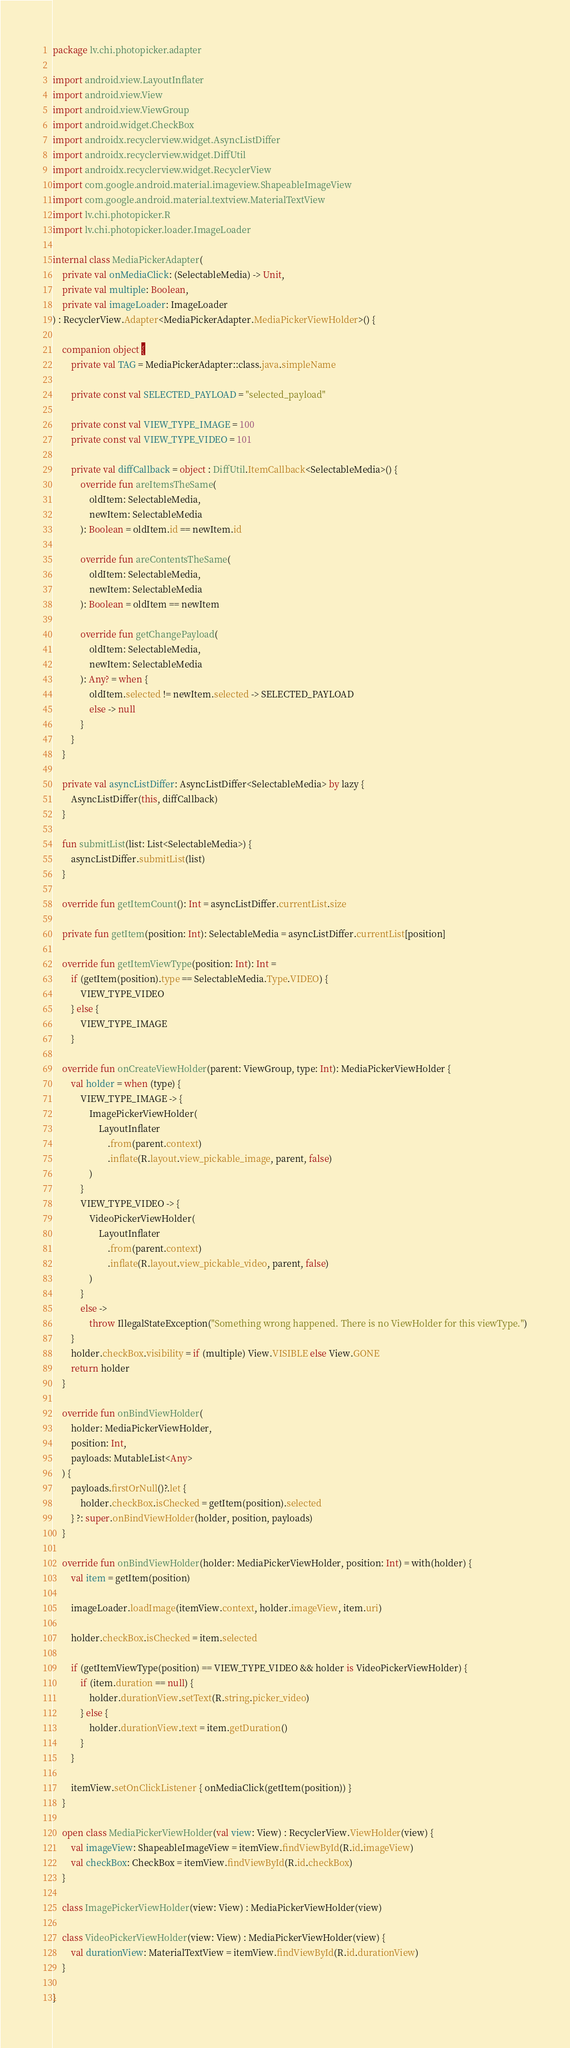Convert code to text. <code><loc_0><loc_0><loc_500><loc_500><_Kotlin_>package lv.chi.photopicker.adapter

import android.view.LayoutInflater
import android.view.View
import android.view.ViewGroup
import android.widget.CheckBox
import androidx.recyclerview.widget.AsyncListDiffer
import androidx.recyclerview.widget.DiffUtil
import androidx.recyclerview.widget.RecyclerView
import com.google.android.material.imageview.ShapeableImageView
import com.google.android.material.textview.MaterialTextView
import lv.chi.photopicker.R
import lv.chi.photopicker.loader.ImageLoader

internal class MediaPickerAdapter(
    private val onMediaClick: (SelectableMedia) -> Unit,
    private val multiple: Boolean,
    private val imageLoader: ImageLoader
) : RecyclerView.Adapter<MediaPickerAdapter.MediaPickerViewHolder>() {

    companion object {
        private val TAG = MediaPickerAdapter::class.java.simpleName

        private const val SELECTED_PAYLOAD = "selected_payload"

        private const val VIEW_TYPE_IMAGE = 100
        private const val VIEW_TYPE_VIDEO = 101

        private val diffCallback = object : DiffUtil.ItemCallback<SelectableMedia>() {
            override fun areItemsTheSame(
                oldItem: SelectableMedia,
                newItem: SelectableMedia
            ): Boolean = oldItem.id == newItem.id

            override fun areContentsTheSame(
                oldItem: SelectableMedia,
                newItem: SelectableMedia
            ): Boolean = oldItem == newItem

            override fun getChangePayload(
                oldItem: SelectableMedia,
                newItem: SelectableMedia
            ): Any? = when {
                oldItem.selected != newItem.selected -> SELECTED_PAYLOAD
                else -> null
            }
        }
    }

    private val asyncListDiffer: AsyncListDiffer<SelectableMedia> by lazy {
        AsyncListDiffer(this, diffCallback)
    }

    fun submitList(list: List<SelectableMedia>) {
        asyncListDiffer.submitList(list)
    }

    override fun getItemCount(): Int = asyncListDiffer.currentList.size

    private fun getItem(position: Int): SelectableMedia = asyncListDiffer.currentList[position]

    override fun getItemViewType(position: Int): Int =
        if (getItem(position).type == SelectableMedia.Type.VIDEO) {
            VIEW_TYPE_VIDEO
        } else {
            VIEW_TYPE_IMAGE
        }

    override fun onCreateViewHolder(parent: ViewGroup, type: Int): MediaPickerViewHolder {
        val holder = when (type) {
            VIEW_TYPE_IMAGE -> {
                ImagePickerViewHolder(
                    LayoutInflater
                        .from(parent.context)
                        .inflate(R.layout.view_pickable_image, parent, false)
                )
            }
            VIEW_TYPE_VIDEO -> {
                VideoPickerViewHolder(
                    LayoutInflater
                        .from(parent.context)
                        .inflate(R.layout.view_pickable_video, parent, false)
                )
            }
            else ->
                throw IllegalStateException("Something wrong happened. There is no ViewHolder for this viewType.")
        }
        holder.checkBox.visibility = if (multiple) View.VISIBLE else View.GONE
        return holder
    }

    override fun onBindViewHolder(
        holder: MediaPickerViewHolder,
        position: Int,
        payloads: MutableList<Any>
    ) {
        payloads.firstOrNull()?.let {
            holder.checkBox.isChecked = getItem(position).selected
        } ?: super.onBindViewHolder(holder, position, payloads)
    }

    override fun onBindViewHolder(holder: MediaPickerViewHolder, position: Int) = with(holder) {
        val item = getItem(position)

        imageLoader.loadImage(itemView.context, holder.imageView, item.uri)

        holder.checkBox.isChecked = item.selected

        if (getItemViewType(position) == VIEW_TYPE_VIDEO && holder is VideoPickerViewHolder) {
            if (item.duration == null) {
                holder.durationView.setText(R.string.picker_video)
            } else {
                holder.durationView.text = item.getDuration()
            }
        }

        itemView.setOnClickListener { onMediaClick(getItem(position)) }
    }

    open class MediaPickerViewHolder(val view: View) : RecyclerView.ViewHolder(view) {
        val imageView: ShapeableImageView = itemView.findViewById(R.id.imageView)
        val checkBox: CheckBox = itemView.findViewById(R.id.checkBox)
    }

    class ImagePickerViewHolder(view: View) : MediaPickerViewHolder(view)

    class VideoPickerViewHolder(view: View) : MediaPickerViewHolder(view) {
        val durationView: MaterialTextView = itemView.findViewById(R.id.durationView)
    }

}</code> 